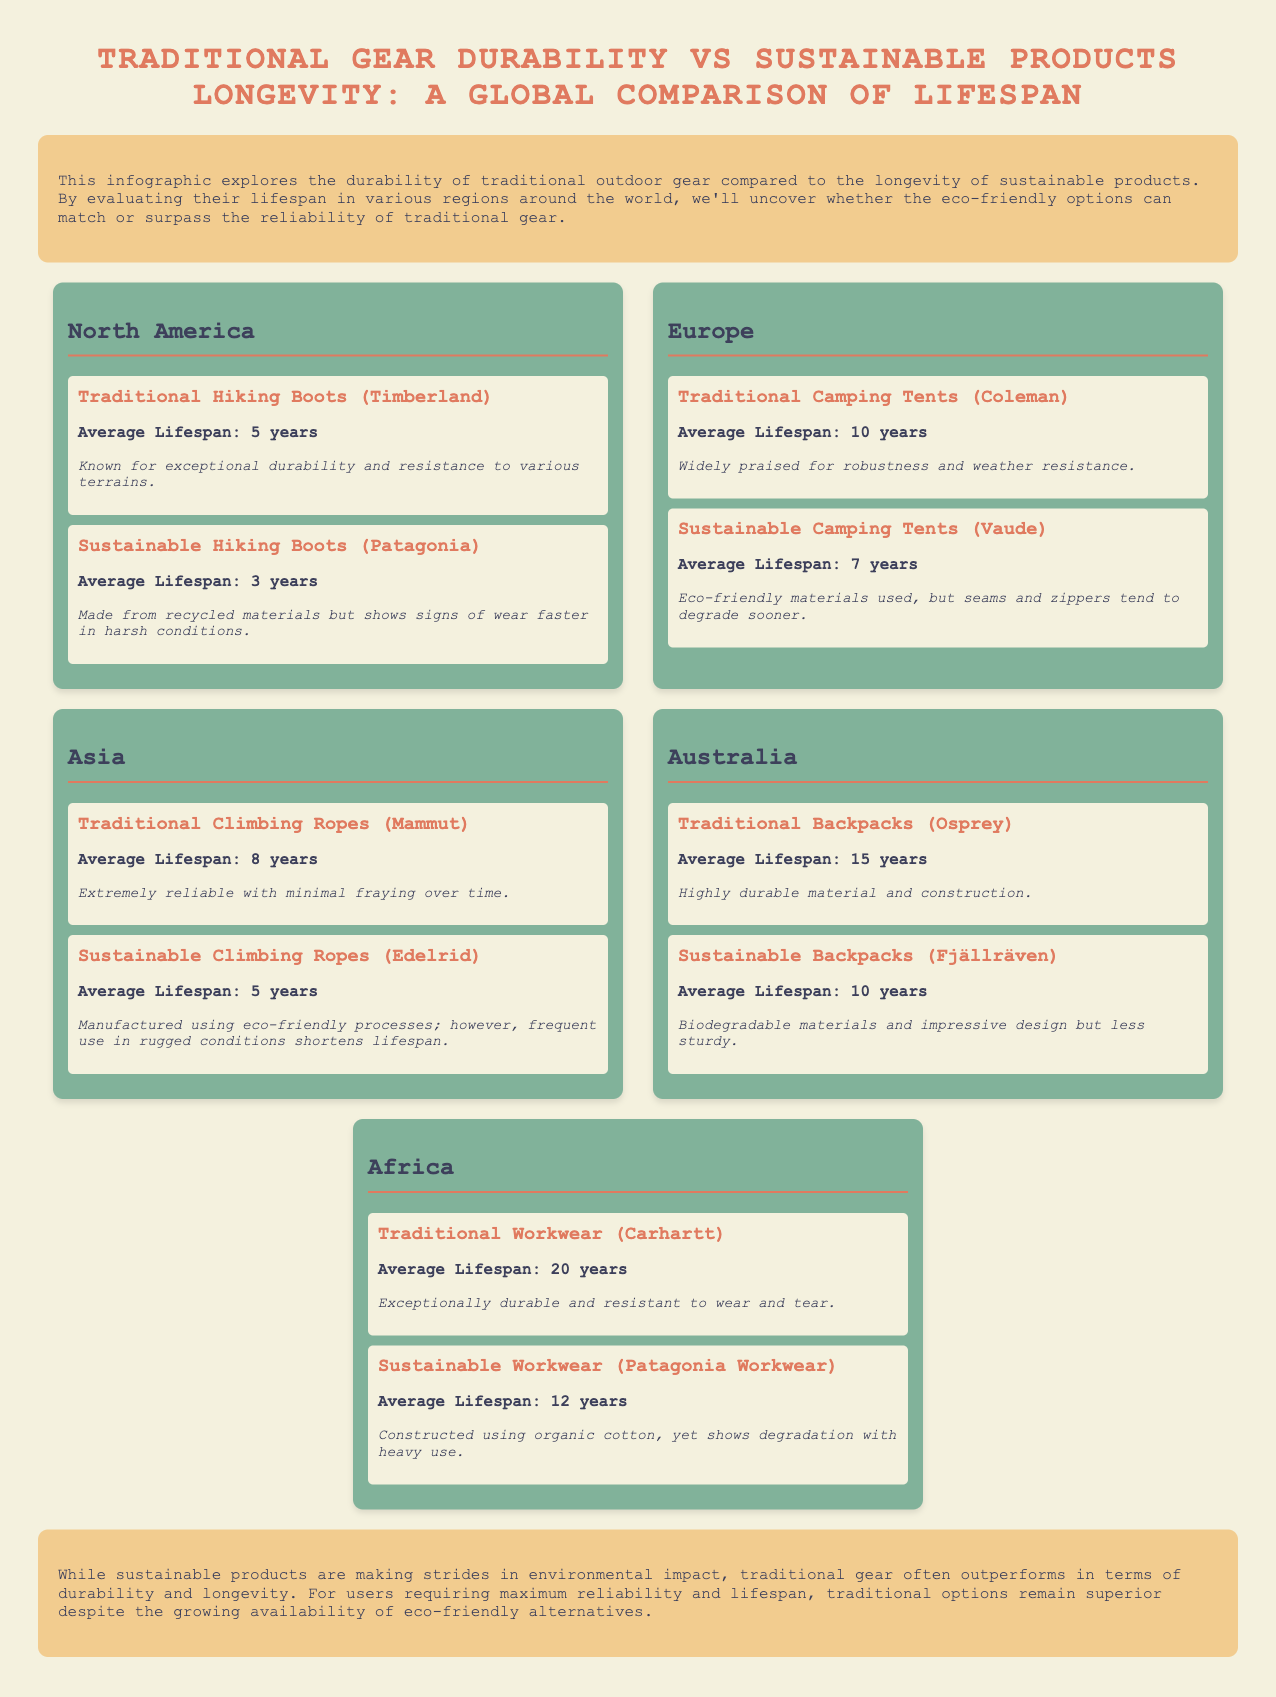What is the average lifespan of traditional hiking boots? The average lifespan of traditional hiking boots (Timberland) in North America is specifically stated in the document as 5 years.
Answer: 5 years What is the lifespan of sustainable backpacks in Australia? The document indicates that sustainable backpacks (Fjällräven) in Australia have an average lifespan of 10 years.
Answer: 10 years Which product has a longer lifespan in Europe, traditional or sustainable camping tents? Comparing the average lifespans provided, traditional camping tents (Coleman) have a lifespan of 10 years, while sustainable camping tents (Vaude) have 7 years, thus traditional tents last longer.
Answer: Traditional camping tents What is the lifespan of traditional workwear in Africa? The document specifies that traditional workwear (Carhartt) has an average lifespan of 20 years.
Answer: 20 years Which traditional gear has the longest average lifespan? Among the products listed, the traditional backpacks (Osprey) in Australia have the longest average lifespan of 15 years.
Answer: Traditional backpacks How much longer do traditional climbing ropes last compared to sustainable ones in Asia? Traditional climbing ropes (Mammut) have an average lifespan of 8 years, while sustainable climbing ropes (Edelrid) last for 5 years, making the difference in lifespan 3 years longer for traditional ones.
Answer: 3 years Which region shows the highest durability for sustainable products? Based on the average lifespans, Africa shows the highest durability for sustainable products with sustainable workwear lasting 12 years, compared to shorter lifespans in other regions.
Answer: Africa Does the conclusion state that sustainable products perform better than traditional gear? The conclusion specifically asserts that traditional gear often outperforms in terms of durability, indicating that sustainable products do not match traditional gear's performance.
Answer: No 